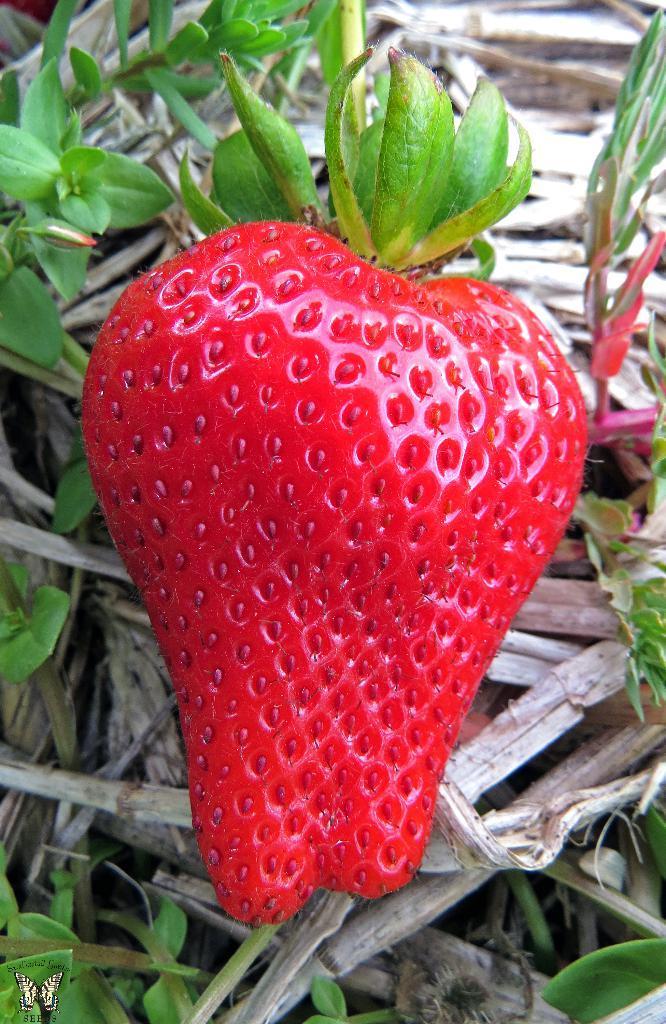In one or two sentences, can you explain what this image depicts? In this image we can see a strawberry, in the background we can see some wood and plants. 